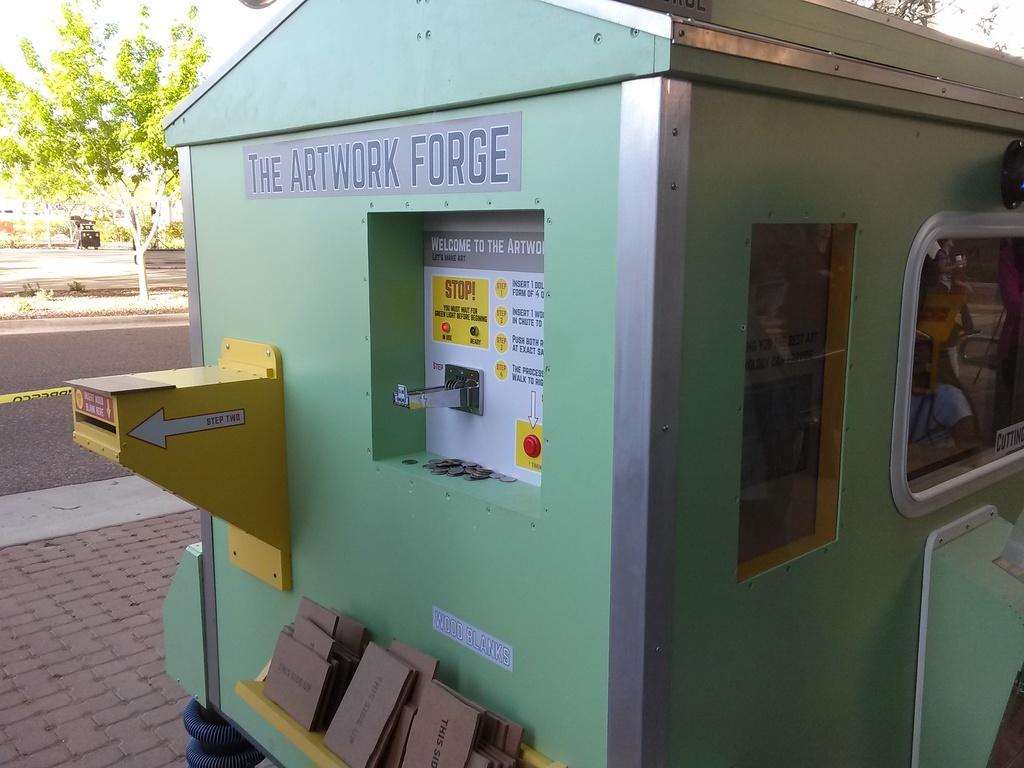<image>
Give a short and clear explanation of the subsequent image. a green box that says the artwork forge has a place to put money in 